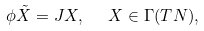<formula> <loc_0><loc_0><loc_500><loc_500>\phi \tilde { X } = J X , \text { \ } X \in \Gamma ( T N ) ,</formula> 